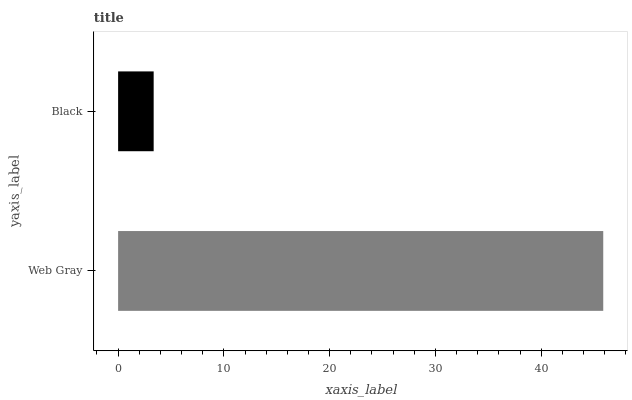Is Black the minimum?
Answer yes or no. Yes. Is Web Gray the maximum?
Answer yes or no. Yes. Is Black the maximum?
Answer yes or no. No. Is Web Gray greater than Black?
Answer yes or no. Yes. Is Black less than Web Gray?
Answer yes or no. Yes. Is Black greater than Web Gray?
Answer yes or no. No. Is Web Gray less than Black?
Answer yes or no. No. Is Web Gray the high median?
Answer yes or no. Yes. Is Black the low median?
Answer yes or no. Yes. Is Black the high median?
Answer yes or no. No. Is Web Gray the low median?
Answer yes or no. No. 